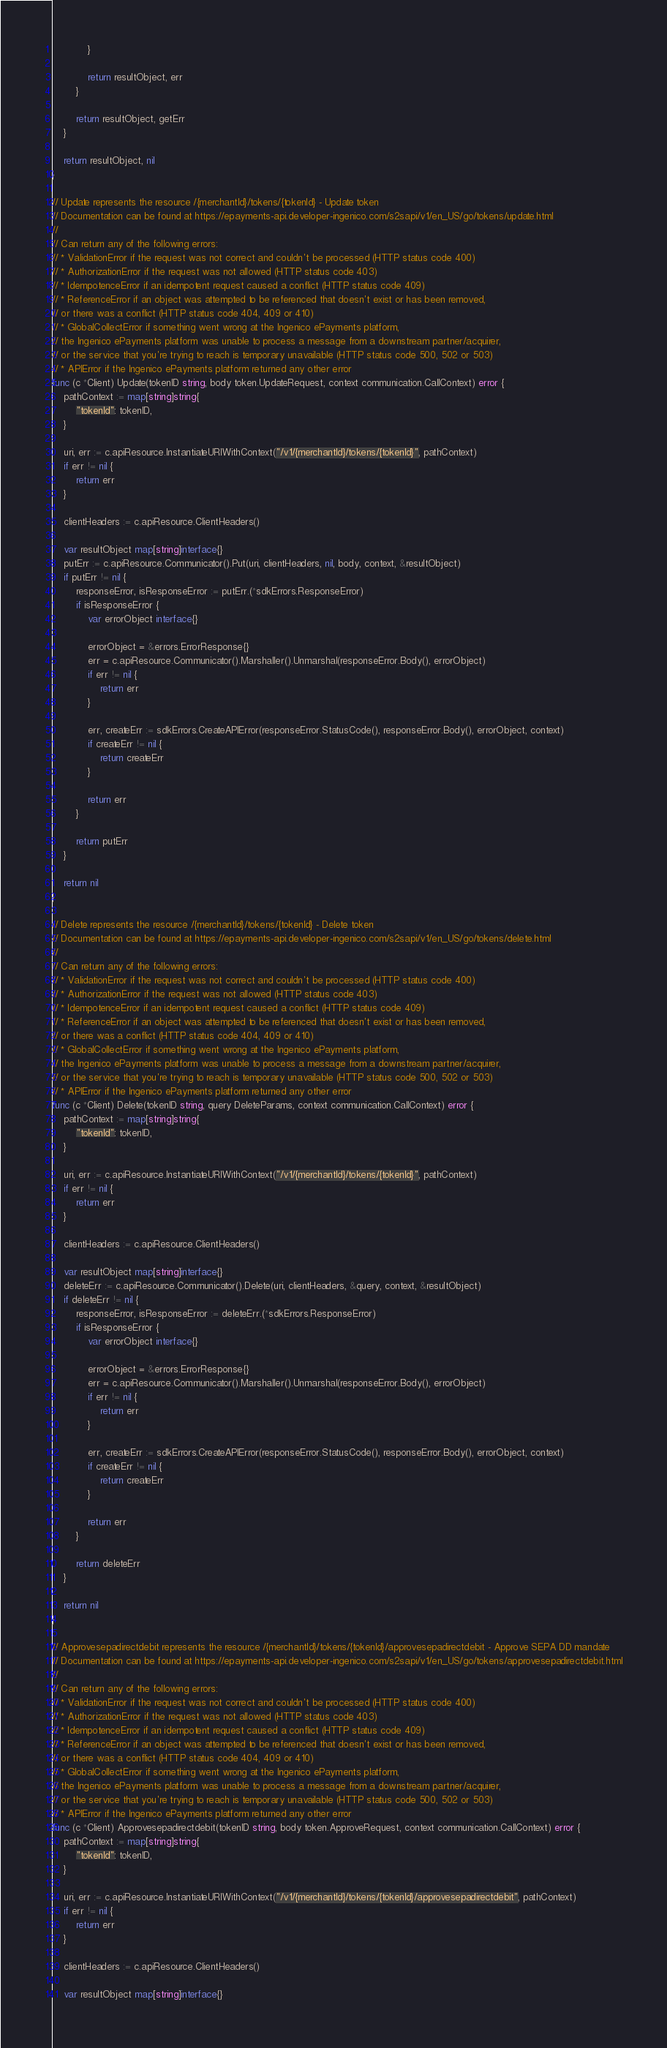Convert code to text. <code><loc_0><loc_0><loc_500><loc_500><_Go_>			}

			return resultObject, err
		}

		return resultObject, getErr
	}

	return resultObject, nil
}

// Update represents the resource /{merchantId}/tokens/{tokenId} - Update token
// Documentation can be found at https://epayments-api.developer-ingenico.com/s2sapi/v1/en_US/go/tokens/update.html
//
// Can return any of the following errors:
// * ValidationError if the request was not correct and couldn't be processed (HTTP status code 400)
// * AuthorizationError if the request was not allowed (HTTP status code 403)
// * IdempotenceError if an idempotent request caused a conflict (HTTP status code 409)
// * ReferenceError if an object was attempted to be referenced that doesn't exist or has been removed,
// or there was a conflict (HTTP status code 404, 409 or 410)
// * GlobalCollectError if something went wrong at the Ingenico ePayments platform,
// the Ingenico ePayments platform was unable to process a message from a downstream partner/acquirer,
// or the service that you're trying to reach is temporary unavailable (HTTP status code 500, 502 or 503)
// * APIError if the Ingenico ePayments platform returned any other error
func (c *Client) Update(tokenID string, body token.UpdateRequest, context communication.CallContext) error {
	pathContext := map[string]string{
		"tokenId": tokenID,
	}

	uri, err := c.apiResource.InstantiateURIWithContext("/v1/{merchantId}/tokens/{tokenId}", pathContext)
	if err != nil {
		return err
	}

	clientHeaders := c.apiResource.ClientHeaders()

	var resultObject map[string]interface{}
	putErr := c.apiResource.Communicator().Put(uri, clientHeaders, nil, body, context, &resultObject)
	if putErr != nil {
		responseError, isResponseError := putErr.(*sdkErrors.ResponseError)
		if isResponseError {
			var errorObject interface{}

			errorObject = &errors.ErrorResponse{}
			err = c.apiResource.Communicator().Marshaller().Unmarshal(responseError.Body(), errorObject)
			if err != nil {
				return err
			}

			err, createErr := sdkErrors.CreateAPIError(responseError.StatusCode(), responseError.Body(), errorObject, context)
			if createErr != nil {
				return createErr
			}

			return err
		}

		return putErr
	}

	return nil
}

// Delete represents the resource /{merchantId}/tokens/{tokenId} - Delete token
// Documentation can be found at https://epayments-api.developer-ingenico.com/s2sapi/v1/en_US/go/tokens/delete.html
//
// Can return any of the following errors:
// * ValidationError if the request was not correct and couldn't be processed (HTTP status code 400)
// * AuthorizationError if the request was not allowed (HTTP status code 403)
// * IdempotenceError if an idempotent request caused a conflict (HTTP status code 409)
// * ReferenceError if an object was attempted to be referenced that doesn't exist or has been removed,
// or there was a conflict (HTTP status code 404, 409 or 410)
// * GlobalCollectError if something went wrong at the Ingenico ePayments platform,
// the Ingenico ePayments platform was unable to process a message from a downstream partner/acquirer,
// or the service that you're trying to reach is temporary unavailable (HTTP status code 500, 502 or 503)
// * APIError if the Ingenico ePayments platform returned any other error
func (c *Client) Delete(tokenID string, query DeleteParams, context communication.CallContext) error {
	pathContext := map[string]string{
		"tokenId": tokenID,
	}

	uri, err := c.apiResource.InstantiateURIWithContext("/v1/{merchantId}/tokens/{tokenId}", pathContext)
	if err != nil {
		return err
	}

	clientHeaders := c.apiResource.ClientHeaders()

	var resultObject map[string]interface{}
	deleteErr := c.apiResource.Communicator().Delete(uri, clientHeaders, &query, context, &resultObject)
	if deleteErr != nil {
		responseError, isResponseError := deleteErr.(*sdkErrors.ResponseError)
		if isResponseError {
			var errorObject interface{}

			errorObject = &errors.ErrorResponse{}
			err = c.apiResource.Communicator().Marshaller().Unmarshal(responseError.Body(), errorObject)
			if err != nil {
				return err
			}

			err, createErr := sdkErrors.CreateAPIError(responseError.StatusCode(), responseError.Body(), errorObject, context)
			if createErr != nil {
				return createErr
			}

			return err
		}

		return deleteErr
	}

	return nil
}

// Approvesepadirectdebit represents the resource /{merchantId}/tokens/{tokenId}/approvesepadirectdebit - Approve SEPA DD mandate
// Documentation can be found at https://epayments-api.developer-ingenico.com/s2sapi/v1/en_US/go/tokens/approvesepadirectdebit.html
//
// Can return any of the following errors:
// * ValidationError if the request was not correct and couldn't be processed (HTTP status code 400)
// * AuthorizationError if the request was not allowed (HTTP status code 403)
// * IdempotenceError if an idempotent request caused a conflict (HTTP status code 409)
// * ReferenceError if an object was attempted to be referenced that doesn't exist or has been removed,
// or there was a conflict (HTTP status code 404, 409 or 410)
// * GlobalCollectError if something went wrong at the Ingenico ePayments platform,
// the Ingenico ePayments platform was unable to process a message from a downstream partner/acquirer,
// or the service that you're trying to reach is temporary unavailable (HTTP status code 500, 502 or 503)
// * APIError if the Ingenico ePayments platform returned any other error
func (c *Client) Approvesepadirectdebit(tokenID string, body token.ApproveRequest, context communication.CallContext) error {
	pathContext := map[string]string{
		"tokenId": tokenID,
	}

	uri, err := c.apiResource.InstantiateURIWithContext("/v1/{merchantId}/tokens/{tokenId}/approvesepadirectdebit", pathContext)
	if err != nil {
		return err
	}

	clientHeaders := c.apiResource.ClientHeaders()

	var resultObject map[string]interface{}</code> 